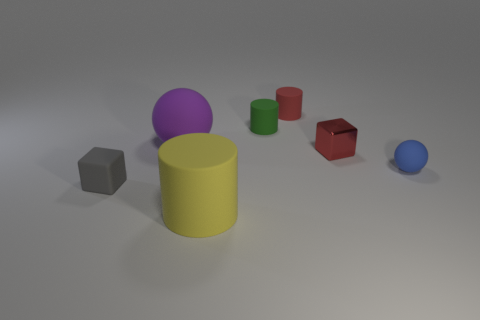Are there more blue matte objects that are in front of the small blue sphere than yellow cylinders? no 